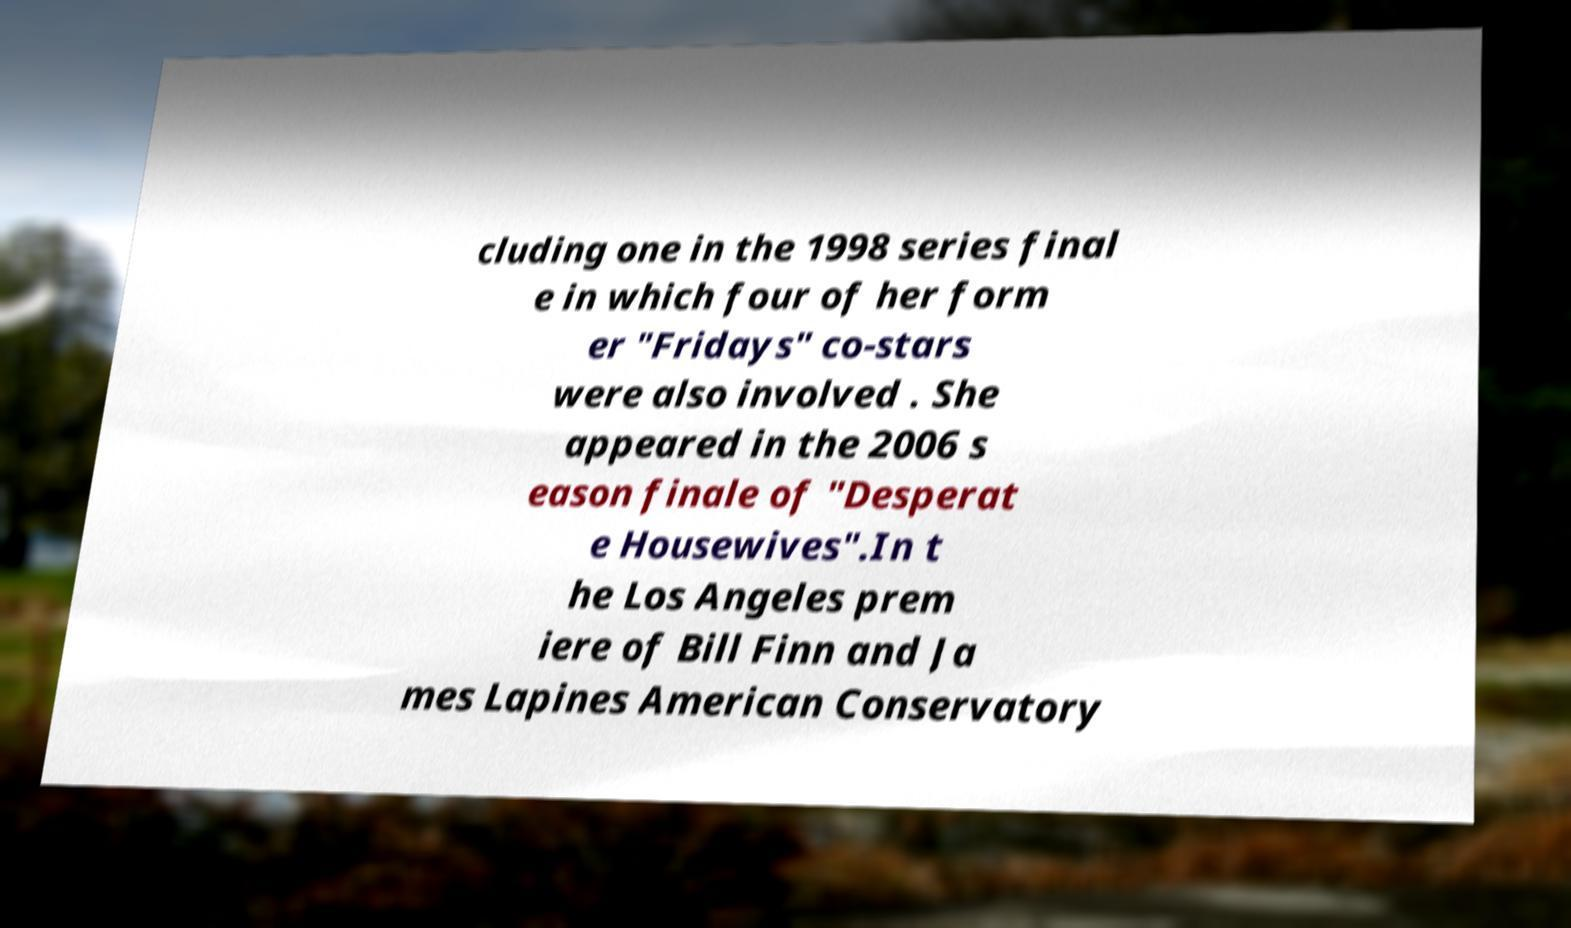I need the written content from this picture converted into text. Can you do that? cluding one in the 1998 series final e in which four of her form er "Fridays" co-stars were also involved . She appeared in the 2006 s eason finale of "Desperat e Housewives".In t he Los Angeles prem iere of Bill Finn and Ja mes Lapines American Conservatory 